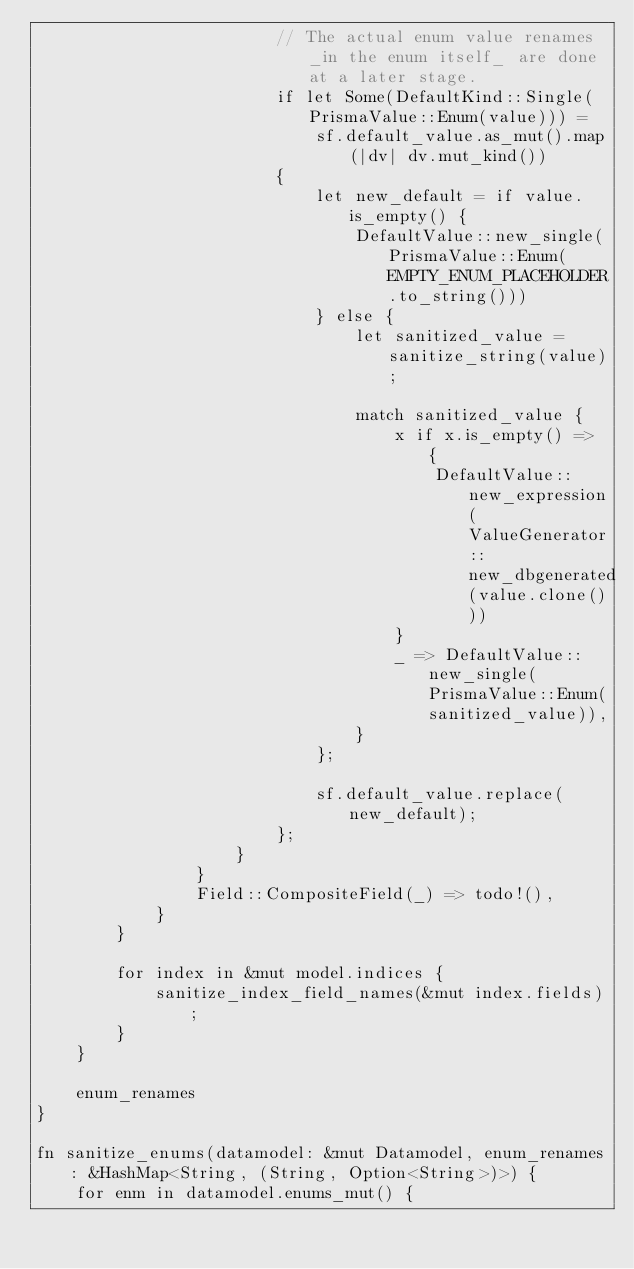<code> <loc_0><loc_0><loc_500><loc_500><_Rust_>                        // The actual enum value renames _in the enum itself_ are done at a later stage.
                        if let Some(DefaultKind::Single(PrismaValue::Enum(value))) =
                            sf.default_value.as_mut().map(|dv| dv.mut_kind())
                        {
                            let new_default = if value.is_empty() {
                                DefaultValue::new_single(PrismaValue::Enum(EMPTY_ENUM_PLACEHOLDER.to_string()))
                            } else {
                                let sanitized_value = sanitize_string(value);

                                match sanitized_value {
                                    x if x.is_empty() => {
                                        DefaultValue::new_expression(ValueGenerator::new_dbgenerated(value.clone()))
                                    }
                                    _ => DefaultValue::new_single(PrismaValue::Enum(sanitized_value)),
                                }
                            };

                            sf.default_value.replace(new_default);
                        };
                    }
                }
                Field::CompositeField(_) => todo!(),
            }
        }

        for index in &mut model.indices {
            sanitize_index_field_names(&mut index.fields);
        }
    }

    enum_renames
}

fn sanitize_enums(datamodel: &mut Datamodel, enum_renames: &HashMap<String, (String, Option<String>)>) {
    for enm in datamodel.enums_mut() {</code> 